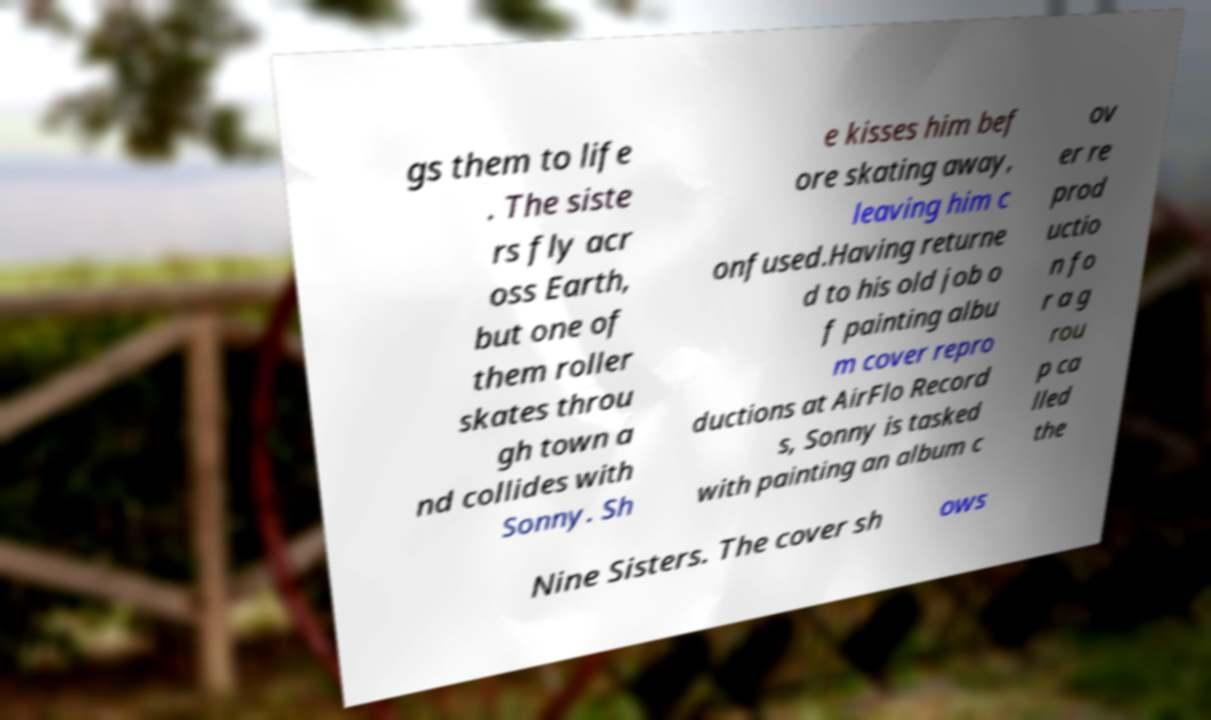What messages or text are displayed in this image? I need them in a readable, typed format. gs them to life . The siste rs fly acr oss Earth, but one of them roller skates throu gh town a nd collides with Sonny. Sh e kisses him bef ore skating away, leaving him c onfused.Having returne d to his old job o f painting albu m cover repro ductions at AirFlo Record s, Sonny is tasked with painting an album c ov er re prod uctio n fo r a g rou p ca lled the Nine Sisters. The cover sh ows 